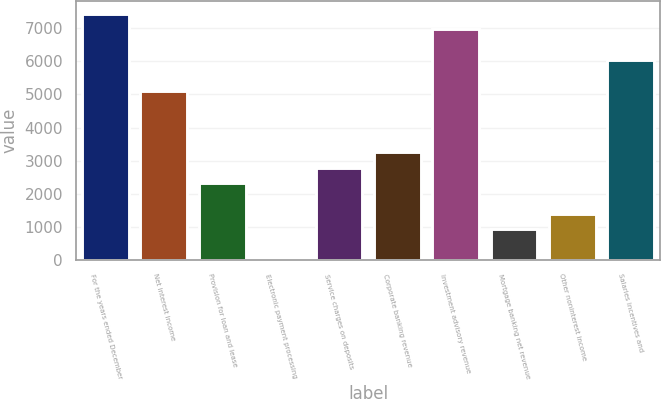Convert chart. <chart><loc_0><loc_0><loc_500><loc_500><bar_chart><fcel>For the years ended December<fcel>Net interest income<fcel>Provision for loan and lease<fcel>Electronic payment processing<fcel>Service charges on deposits<fcel>Corporate banking revenue<fcel>Investment advisory revenue<fcel>Mortgage banking net revenue<fcel>Other noninterest income<fcel>Salaries incentives and<nl><fcel>7441<fcel>5116<fcel>2326<fcel>1<fcel>2791<fcel>3256<fcel>6976<fcel>931<fcel>1396<fcel>6046<nl></chart> 